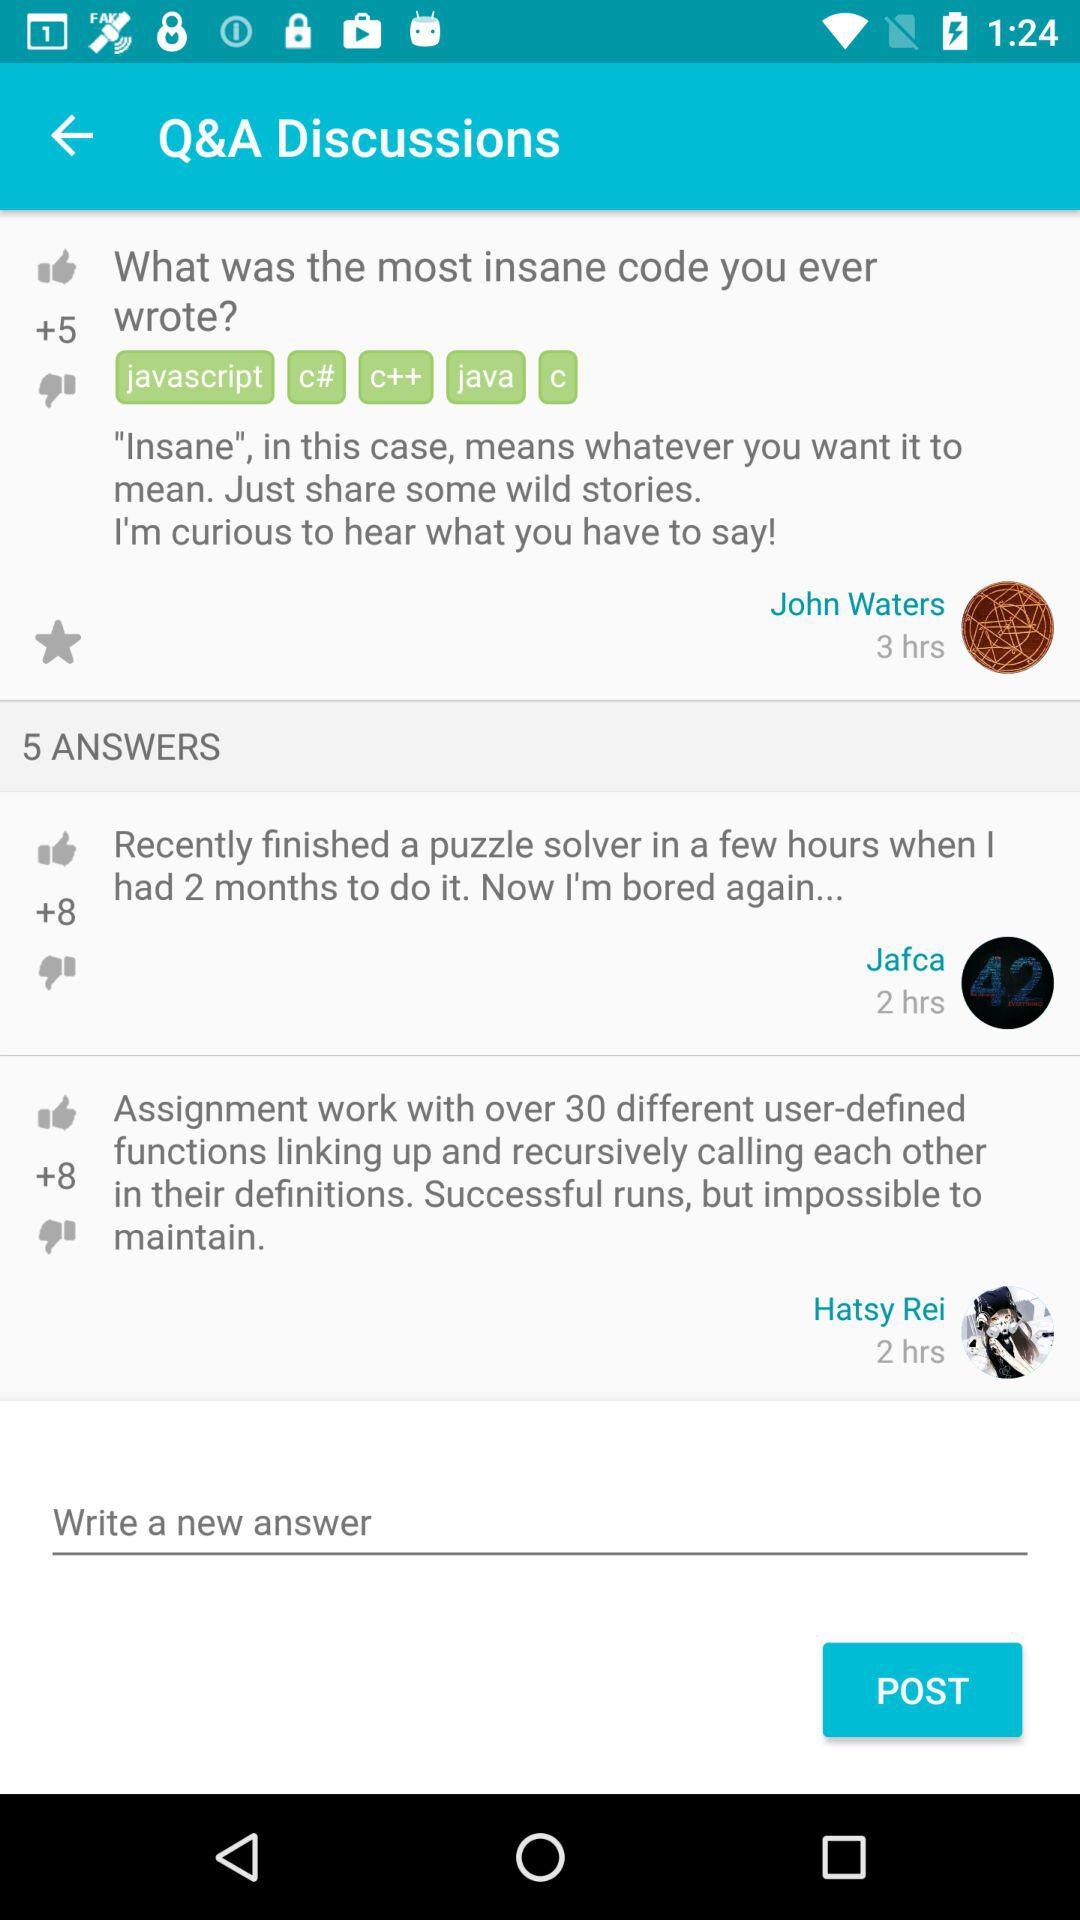How long has it been since the question was asked? It's been 3 hours since the question was asked. 